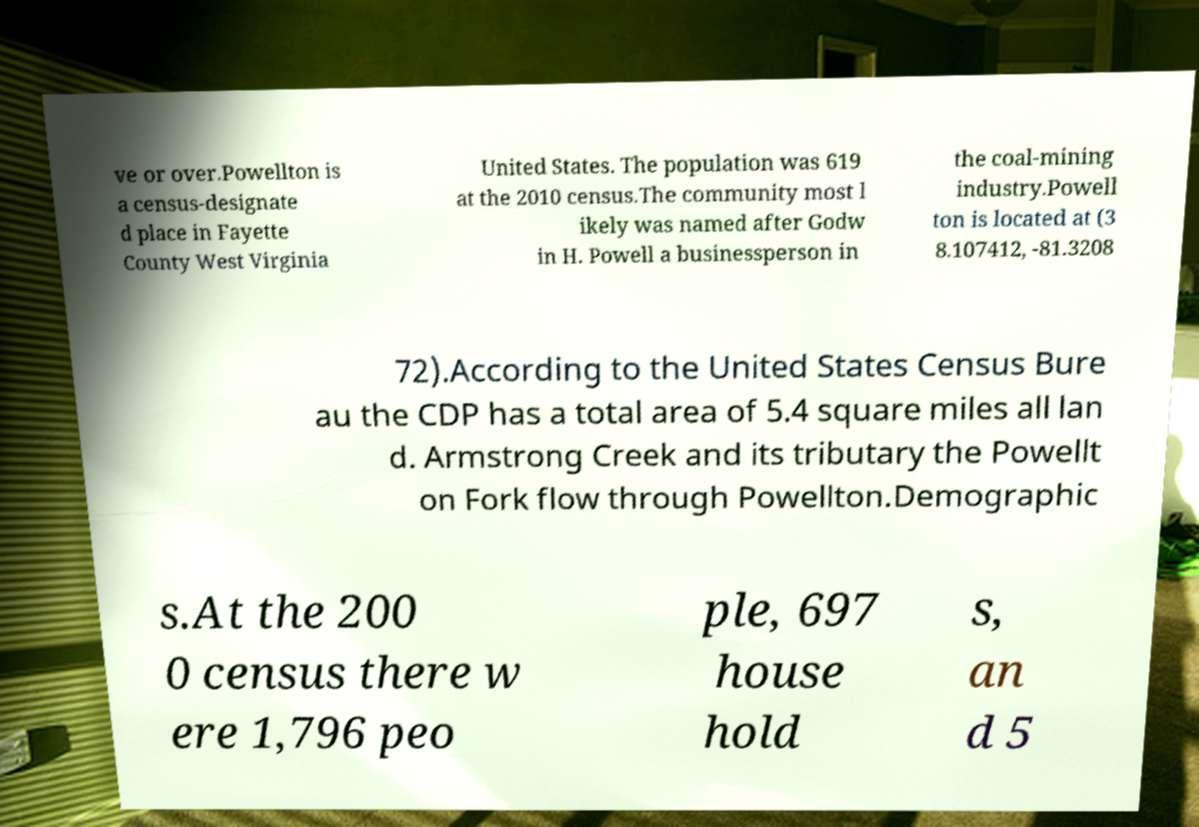There's text embedded in this image that I need extracted. Can you transcribe it verbatim? ve or over.Powellton is a census-designate d place in Fayette County West Virginia United States. The population was 619 at the 2010 census.The community most l ikely was named after Godw in H. Powell a businessperson in the coal-mining industry.Powell ton is located at (3 8.107412, -81.3208 72).According to the United States Census Bure au the CDP has a total area of 5.4 square miles all lan d. Armstrong Creek and its tributary the Powellt on Fork flow through Powellton.Demographic s.At the 200 0 census there w ere 1,796 peo ple, 697 house hold s, an d 5 